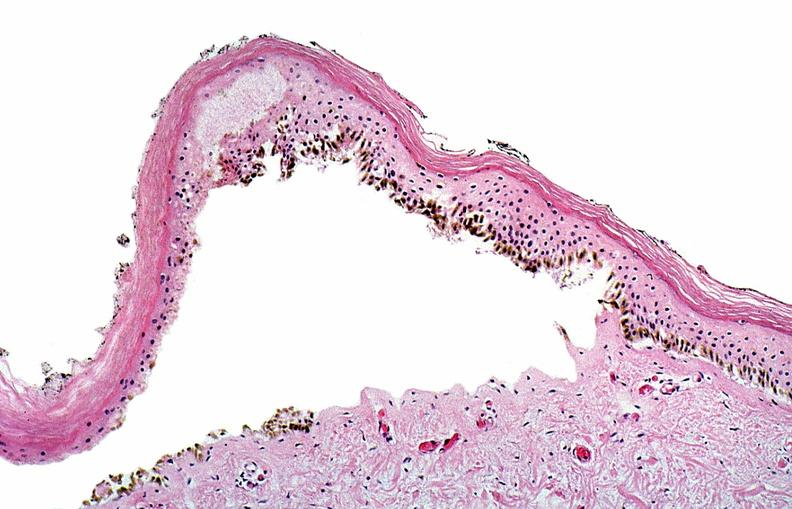does malaria plasmodium vivax show thermal burned skin?
Answer the question using a single word or phrase. No 